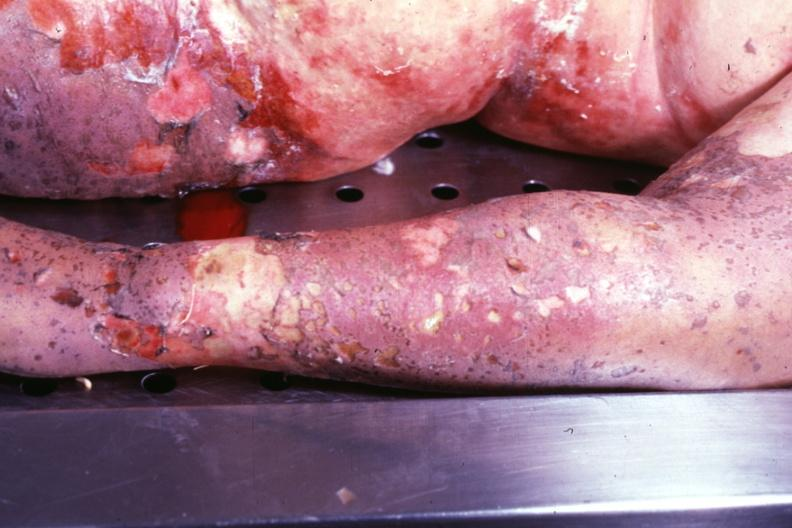s large gland present?
Answer the question using a single word or phrase. No 